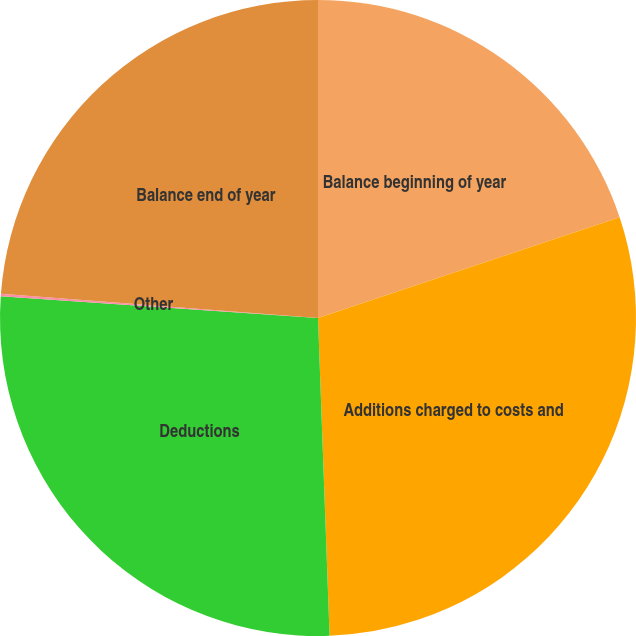<chart> <loc_0><loc_0><loc_500><loc_500><pie_chart><fcel>Balance beginning of year<fcel>Additions charged to costs and<fcel>Deductions<fcel>Other<fcel>Balance end of year<nl><fcel>19.87%<fcel>29.55%<fcel>26.67%<fcel>0.12%<fcel>23.79%<nl></chart> 